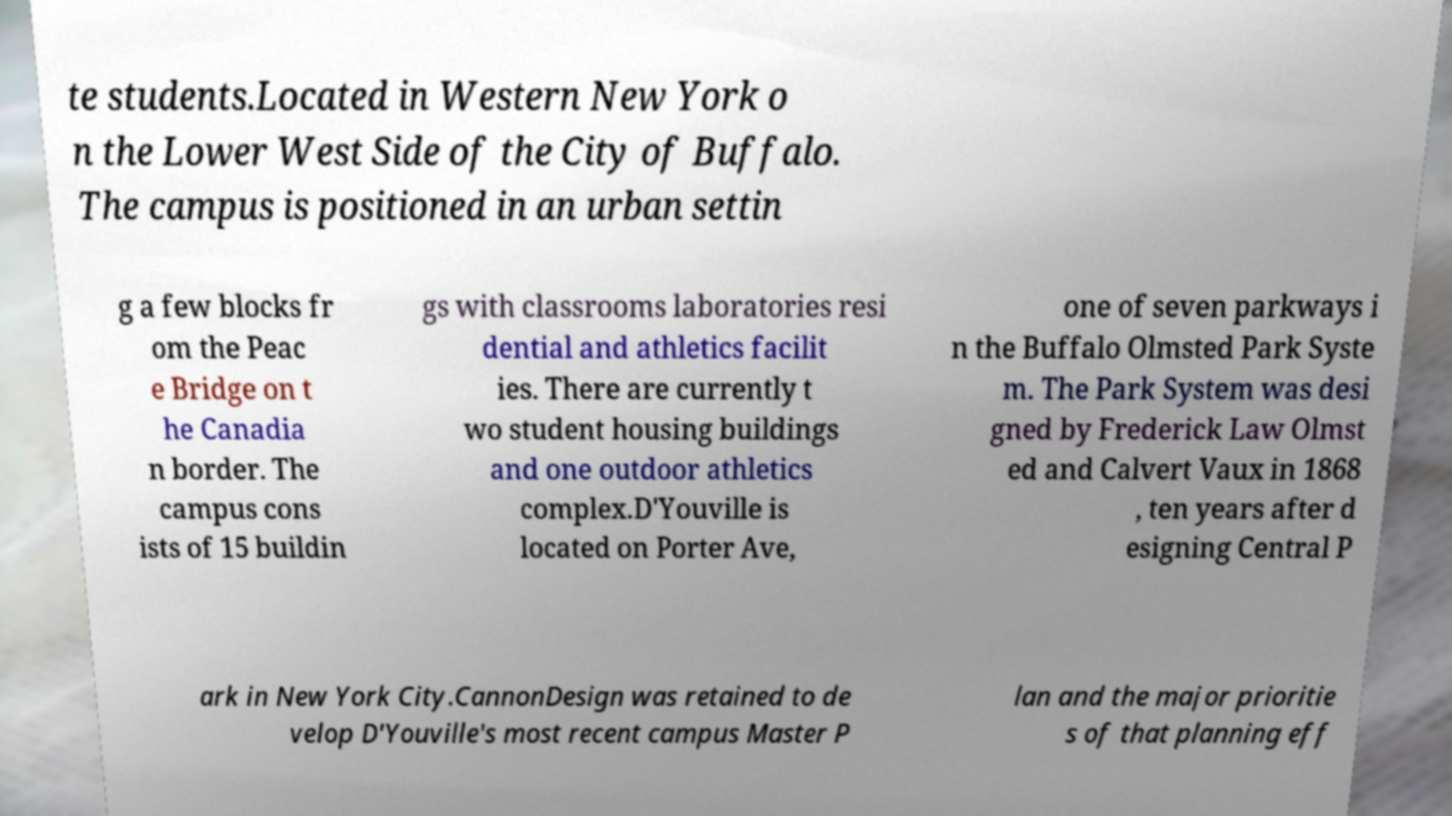For documentation purposes, I need the text within this image transcribed. Could you provide that? te students.Located in Western New York o n the Lower West Side of the City of Buffalo. The campus is positioned in an urban settin g a few blocks fr om the Peac e Bridge on t he Canadia n border. The campus cons ists of 15 buildin gs with classrooms laboratories resi dential and athletics facilit ies. There are currently t wo student housing buildings and one outdoor athletics complex.D'Youville is located on Porter Ave, one of seven parkways i n the Buffalo Olmsted Park Syste m. The Park System was desi gned by Frederick Law Olmst ed and Calvert Vaux in 1868 , ten years after d esigning Central P ark in New York City.CannonDesign was retained to de velop D'Youville's most recent campus Master P lan and the major prioritie s of that planning eff 